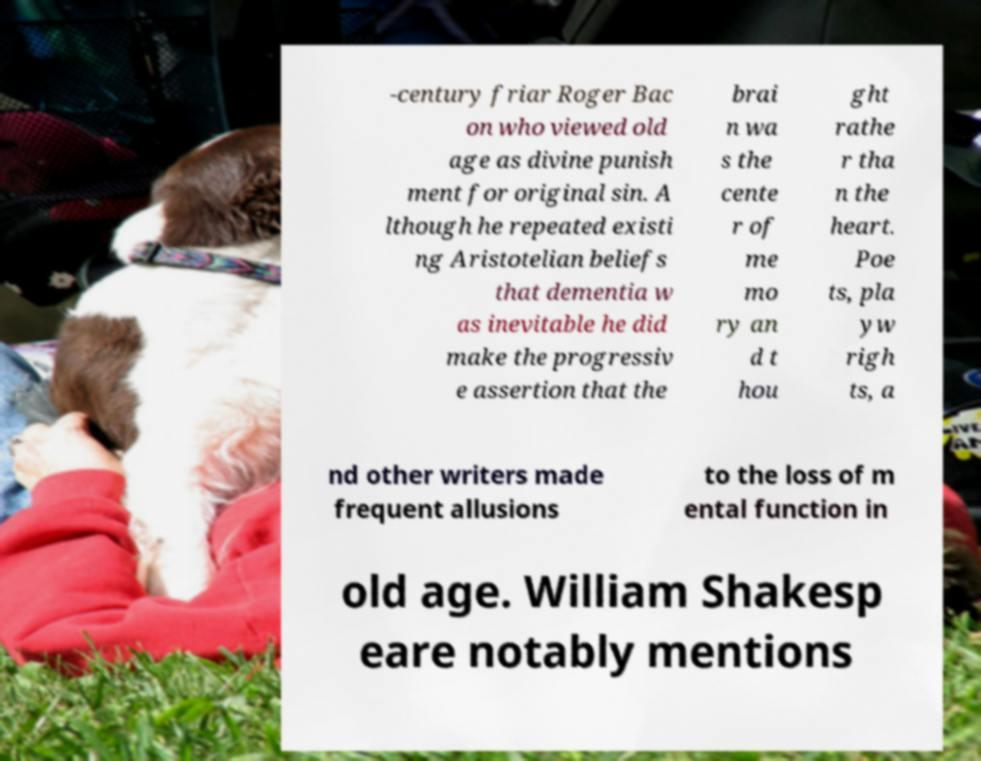What messages or text are displayed in this image? I need them in a readable, typed format. -century friar Roger Bac on who viewed old age as divine punish ment for original sin. A lthough he repeated existi ng Aristotelian beliefs that dementia w as inevitable he did make the progressiv e assertion that the brai n wa s the cente r of me mo ry an d t hou ght rathe r tha n the heart. Poe ts, pla yw righ ts, a nd other writers made frequent allusions to the loss of m ental function in old age. William Shakesp eare notably mentions 